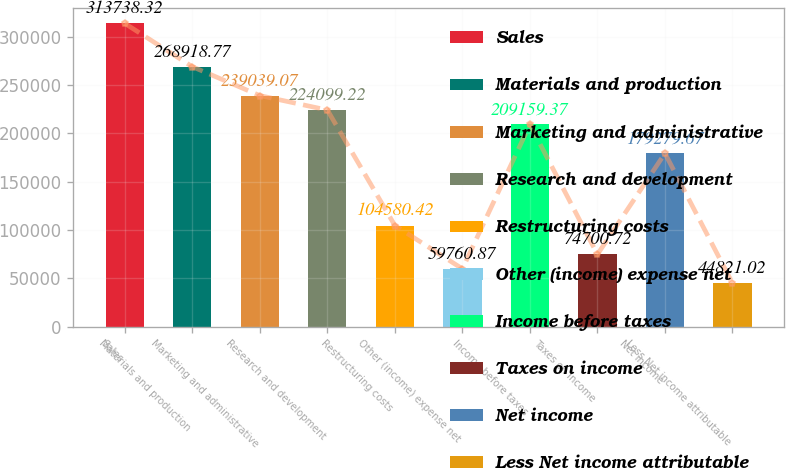<chart> <loc_0><loc_0><loc_500><loc_500><bar_chart><fcel>Sales<fcel>Materials and production<fcel>Marketing and administrative<fcel>Research and development<fcel>Restructuring costs<fcel>Other (income) expense net<fcel>Income before taxes<fcel>Taxes on income<fcel>Net income<fcel>Less Net income attributable<nl><fcel>313738<fcel>268919<fcel>239039<fcel>224099<fcel>104580<fcel>59760.9<fcel>209159<fcel>74700.7<fcel>179280<fcel>44821<nl></chart> 